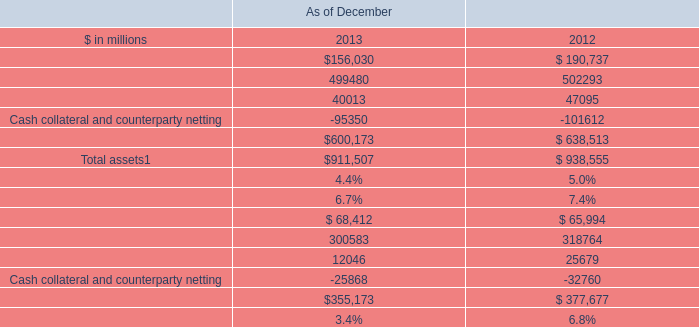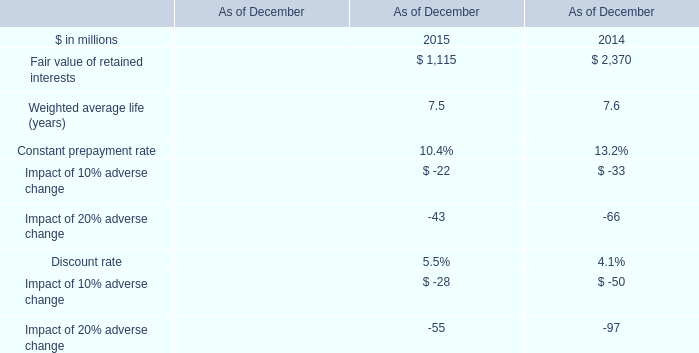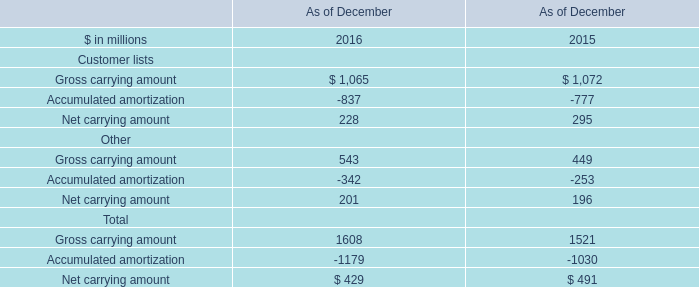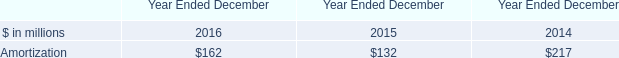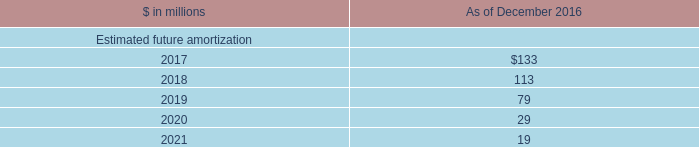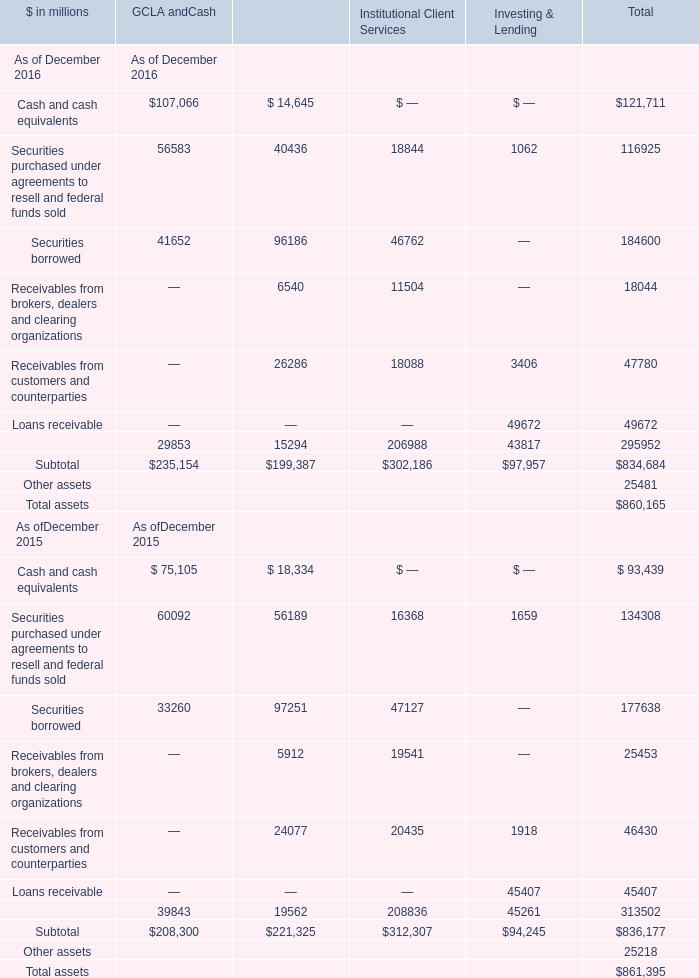What's the 80 % of the Financial instruments owned, at fair value for GCLA and Cash as of December 2016? (in million) 
Computations: (0.8 * 29853)
Answer: 23882.4. 